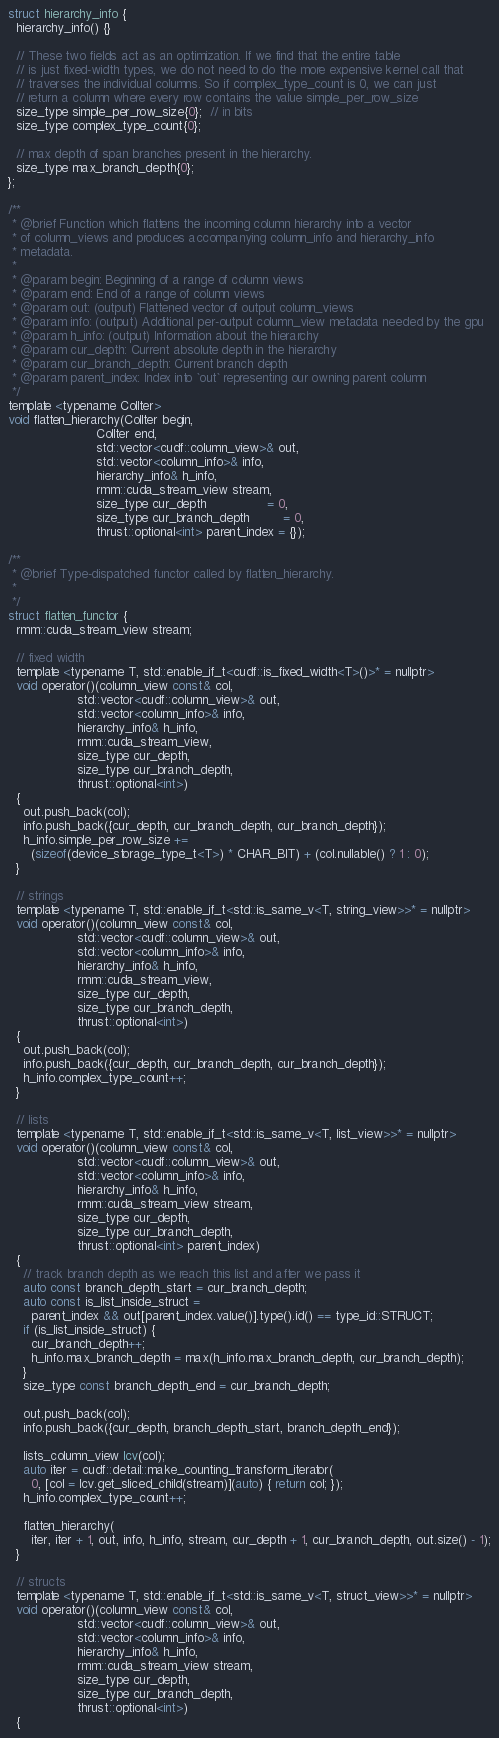<code> <loc_0><loc_0><loc_500><loc_500><_Cuda_>struct hierarchy_info {
  hierarchy_info() {}

  // These two fields act as an optimization. If we find that the entire table
  // is just fixed-width types, we do not need to do the more expensive kernel call that
  // traverses the individual columns. So if complex_type_count is 0, we can just
  // return a column where every row contains the value simple_per_row_size
  size_type simple_per_row_size{0};  // in bits
  size_type complex_type_count{0};

  // max depth of span branches present in the hierarchy.
  size_type max_branch_depth{0};
};

/**
 * @brief Function which flattens the incoming column hierarchy into a vector
 * of column_views and produces accompanying column_info and hierarchy_info
 * metadata.
 *
 * @param begin: Beginning of a range of column views
 * @param end: End of a range of column views
 * @param out: (output) Flattened vector of output column_views
 * @param info: (output) Additional per-output column_view metadata needed by the gpu
 * @param h_info: (output) Information about the hierarchy
 * @param cur_depth: Current absolute depth in the hierarchy
 * @param cur_branch_depth: Current branch depth
 * @param parent_index: Index into `out` representing our owning parent column
 */
template <typename ColIter>
void flatten_hierarchy(ColIter begin,
                       ColIter end,
                       std::vector<cudf::column_view>& out,
                       std::vector<column_info>& info,
                       hierarchy_info& h_info,
                       rmm::cuda_stream_view stream,
                       size_type cur_depth                = 0,
                       size_type cur_branch_depth         = 0,
                       thrust::optional<int> parent_index = {});

/**
 * @brief Type-dispatched functor called by flatten_hierarchy.
 *
 */
struct flatten_functor {
  rmm::cuda_stream_view stream;

  // fixed width
  template <typename T, std::enable_if_t<cudf::is_fixed_width<T>()>* = nullptr>
  void operator()(column_view const& col,
                  std::vector<cudf::column_view>& out,
                  std::vector<column_info>& info,
                  hierarchy_info& h_info,
                  rmm::cuda_stream_view,
                  size_type cur_depth,
                  size_type cur_branch_depth,
                  thrust::optional<int>)
  {
    out.push_back(col);
    info.push_back({cur_depth, cur_branch_depth, cur_branch_depth});
    h_info.simple_per_row_size +=
      (sizeof(device_storage_type_t<T>) * CHAR_BIT) + (col.nullable() ? 1 : 0);
  }

  // strings
  template <typename T, std::enable_if_t<std::is_same_v<T, string_view>>* = nullptr>
  void operator()(column_view const& col,
                  std::vector<cudf::column_view>& out,
                  std::vector<column_info>& info,
                  hierarchy_info& h_info,
                  rmm::cuda_stream_view,
                  size_type cur_depth,
                  size_type cur_branch_depth,
                  thrust::optional<int>)
  {
    out.push_back(col);
    info.push_back({cur_depth, cur_branch_depth, cur_branch_depth});
    h_info.complex_type_count++;
  }

  // lists
  template <typename T, std::enable_if_t<std::is_same_v<T, list_view>>* = nullptr>
  void operator()(column_view const& col,
                  std::vector<cudf::column_view>& out,
                  std::vector<column_info>& info,
                  hierarchy_info& h_info,
                  rmm::cuda_stream_view stream,
                  size_type cur_depth,
                  size_type cur_branch_depth,
                  thrust::optional<int> parent_index)
  {
    // track branch depth as we reach this list and after we pass it
    auto const branch_depth_start = cur_branch_depth;
    auto const is_list_inside_struct =
      parent_index && out[parent_index.value()].type().id() == type_id::STRUCT;
    if (is_list_inside_struct) {
      cur_branch_depth++;
      h_info.max_branch_depth = max(h_info.max_branch_depth, cur_branch_depth);
    }
    size_type const branch_depth_end = cur_branch_depth;

    out.push_back(col);
    info.push_back({cur_depth, branch_depth_start, branch_depth_end});

    lists_column_view lcv(col);
    auto iter = cudf::detail::make_counting_transform_iterator(
      0, [col = lcv.get_sliced_child(stream)](auto) { return col; });
    h_info.complex_type_count++;

    flatten_hierarchy(
      iter, iter + 1, out, info, h_info, stream, cur_depth + 1, cur_branch_depth, out.size() - 1);
  }

  // structs
  template <typename T, std::enable_if_t<std::is_same_v<T, struct_view>>* = nullptr>
  void operator()(column_view const& col,
                  std::vector<cudf::column_view>& out,
                  std::vector<column_info>& info,
                  hierarchy_info& h_info,
                  rmm::cuda_stream_view stream,
                  size_type cur_depth,
                  size_type cur_branch_depth,
                  thrust::optional<int>)
  {</code> 